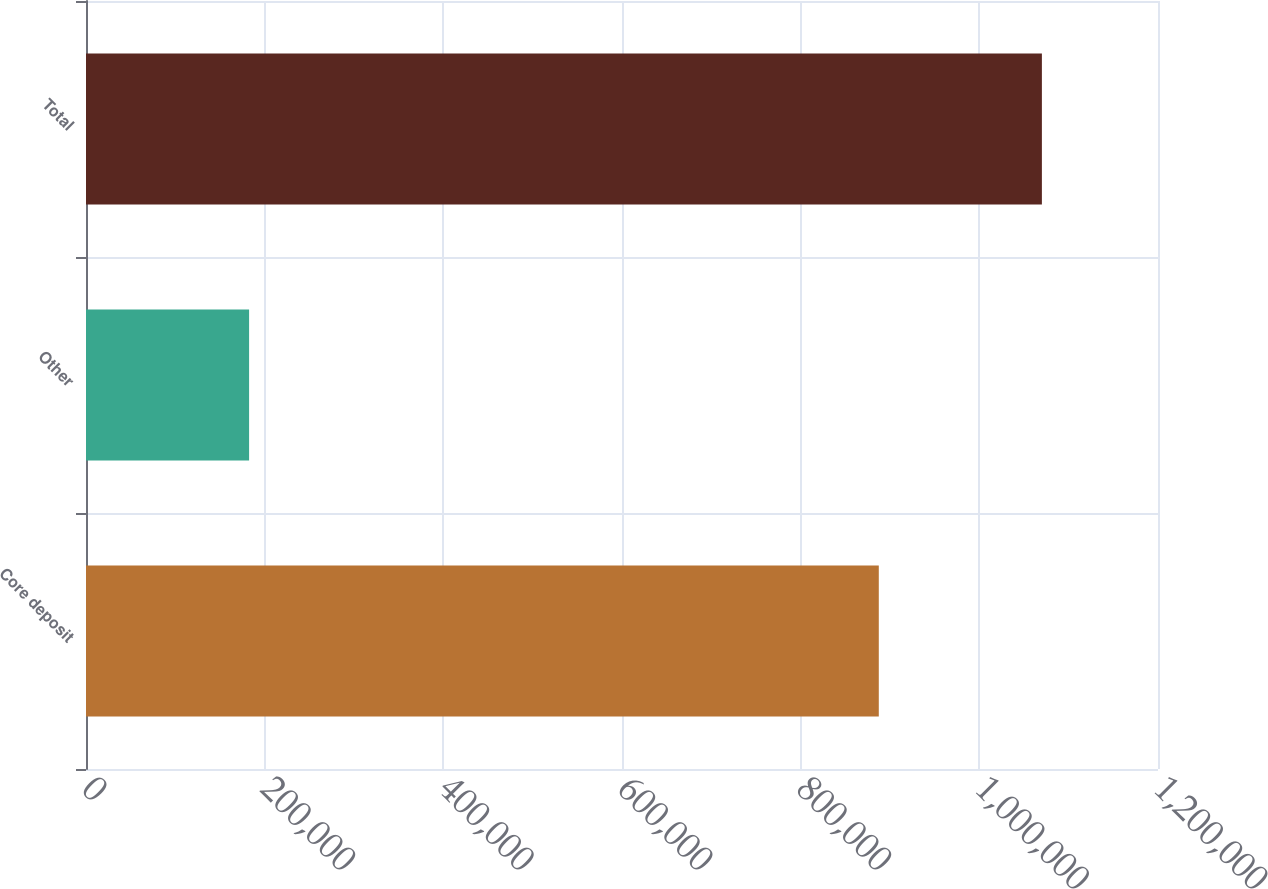Convert chart. <chart><loc_0><loc_0><loc_500><loc_500><bar_chart><fcel>Core deposit<fcel>Other<fcel>Total<nl><fcel>887459<fcel>182568<fcel>1.07003e+06<nl></chart> 